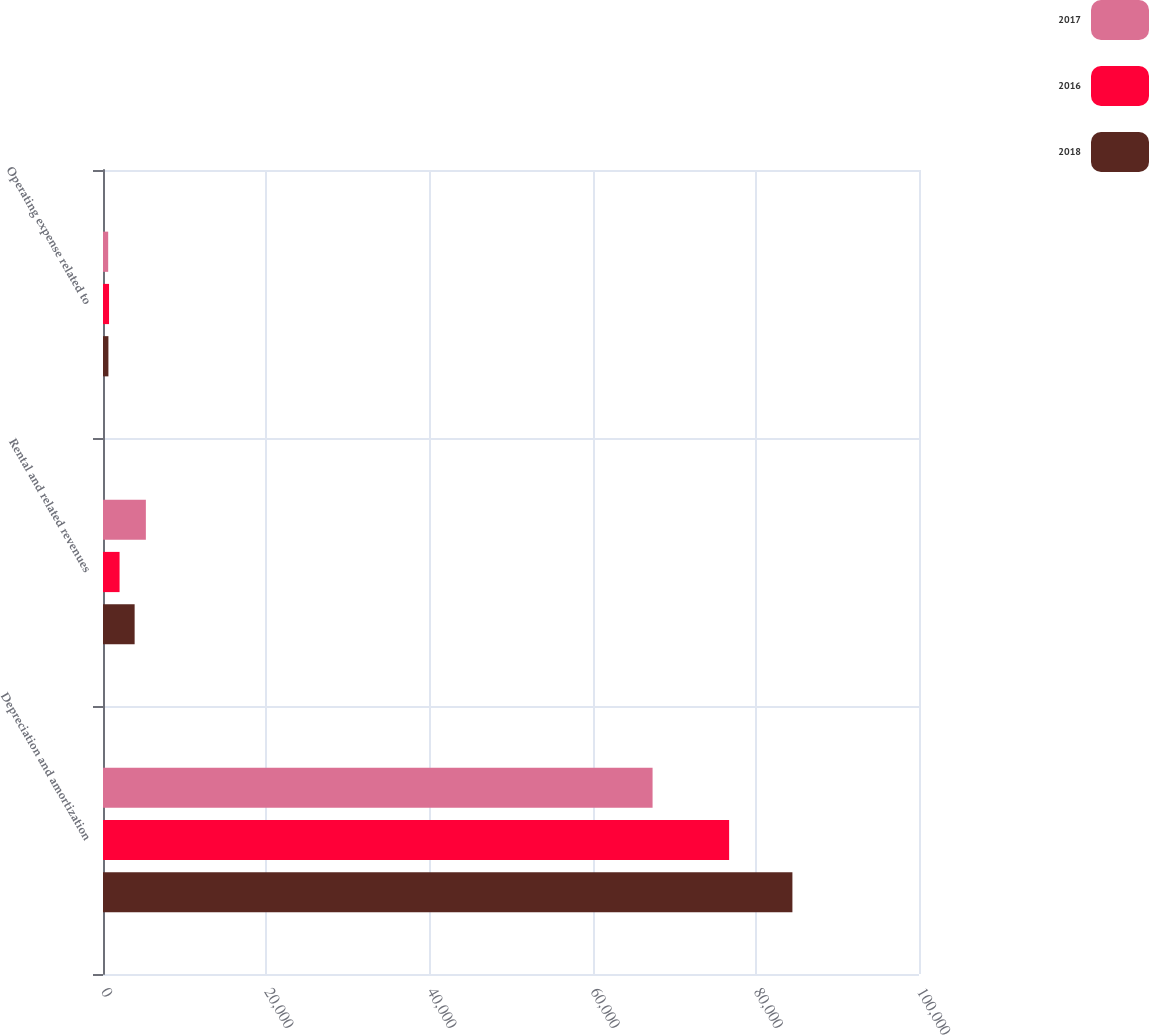<chart> <loc_0><loc_0><loc_500><loc_500><stacked_bar_chart><ecel><fcel>Depreciation and amortization<fcel>Rental and related revenues<fcel>Operating expense related to<nl><fcel>2017<fcel>67350<fcel>5253<fcel>636<nl><fcel>2016<fcel>76732<fcel>2030<fcel>740<nl><fcel>2018<fcel>84487<fcel>3877<fcel>664<nl></chart> 